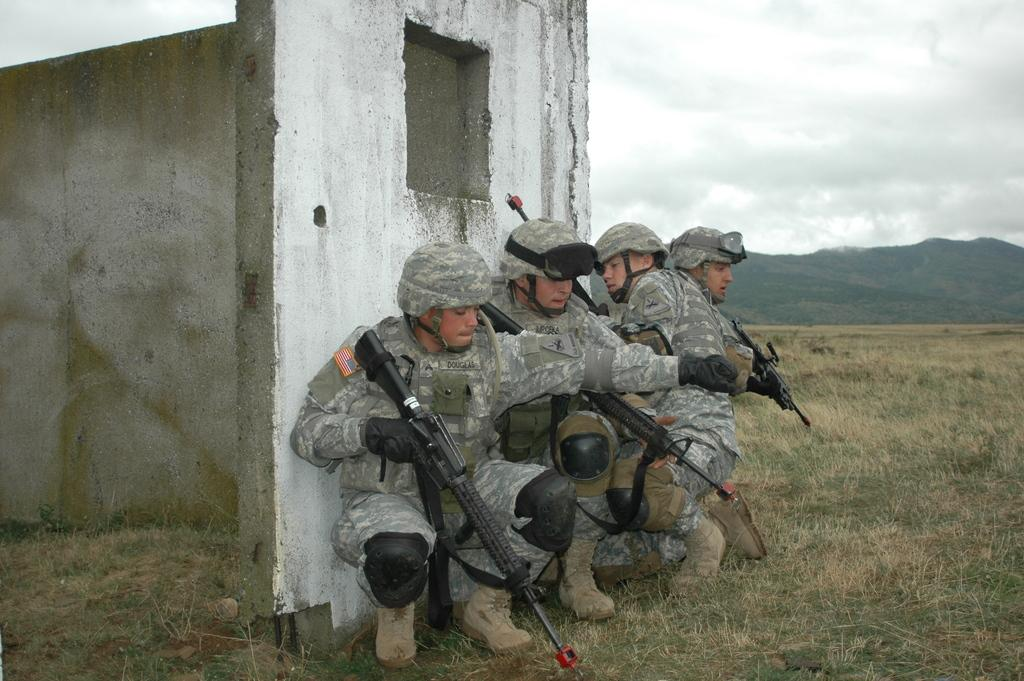How many men are in the image? There are four men in the image. What are the men wearing on their heads? The men are wearing helmets. What type of footwear are the men wearing? The men are wearing shoes. What are the men holding in their hands? The men are holding guns. What can be seen in the background of the image? There is a wall, grass, mountains, and the sky visible in the background. What is the condition of the sky in the image? The sky is visible in the background, and clouds are present. Can you tell me the weight of the kitty playing with the cart in the image? There is no kitty or cart present in the image. What type of cart is being used by the men in the image? There is no cart present in the image; the men are holding guns. 